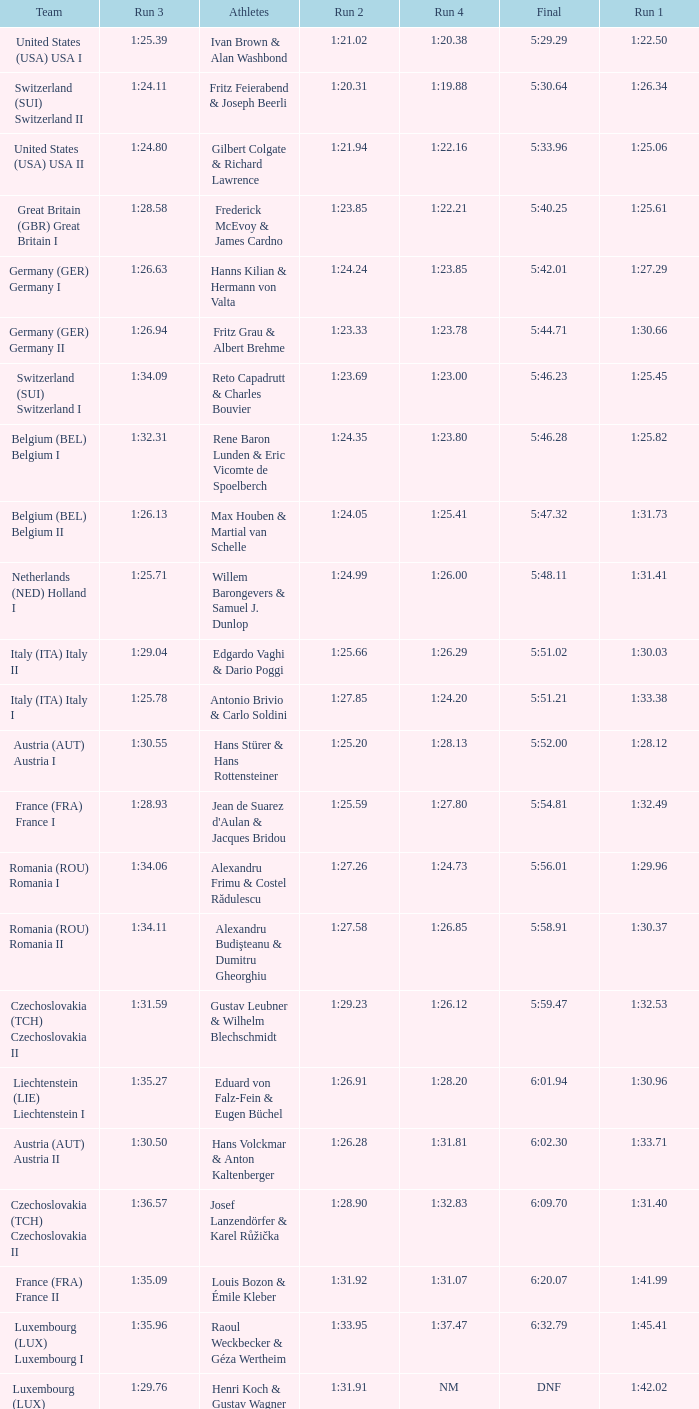Which Run 4 has a Run 1 of 1:25.82? 1:23.80. 